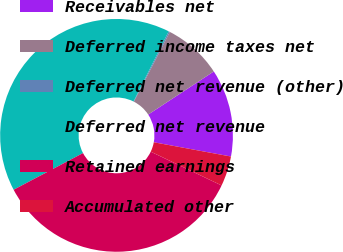<chart> <loc_0><loc_0><loc_500><loc_500><pie_chart><fcel>Receivables net<fcel>Deferred income taxes net<fcel>Deferred net revenue (other)<fcel>Deferred net revenue<fcel>Retained earnings<fcel>Accumulated other<nl><fcel>12.16%<fcel>8.17%<fcel>0.18%<fcel>40.13%<fcel>35.18%<fcel>4.17%<nl></chart> 